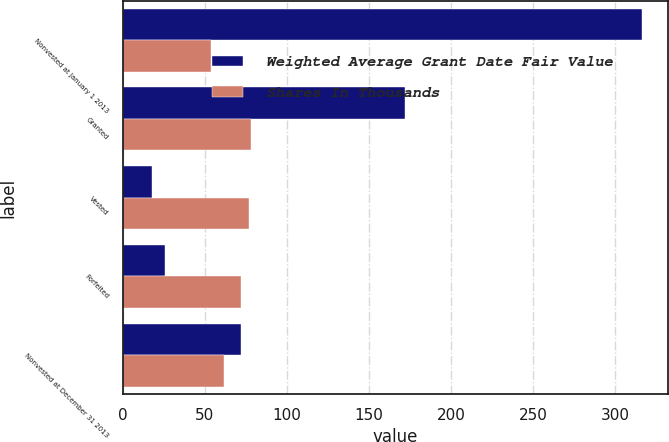<chart> <loc_0><loc_0><loc_500><loc_500><stacked_bar_chart><ecel><fcel>Nonvested at January 1 2013<fcel>Granted<fcel>Vested<fcel>Forfeited<fcel>Nonvested at December 31 2013<nl><fcel>Weighted Average Grant Date Fair Value<fcel>316<fcel>172<fcel>18<fcel>26<fcel>72<nl><fcel>Shares In Thousands<fcel>54<fcel>78<fcel>77<fcel>72<fcel>62<nl></chart> 